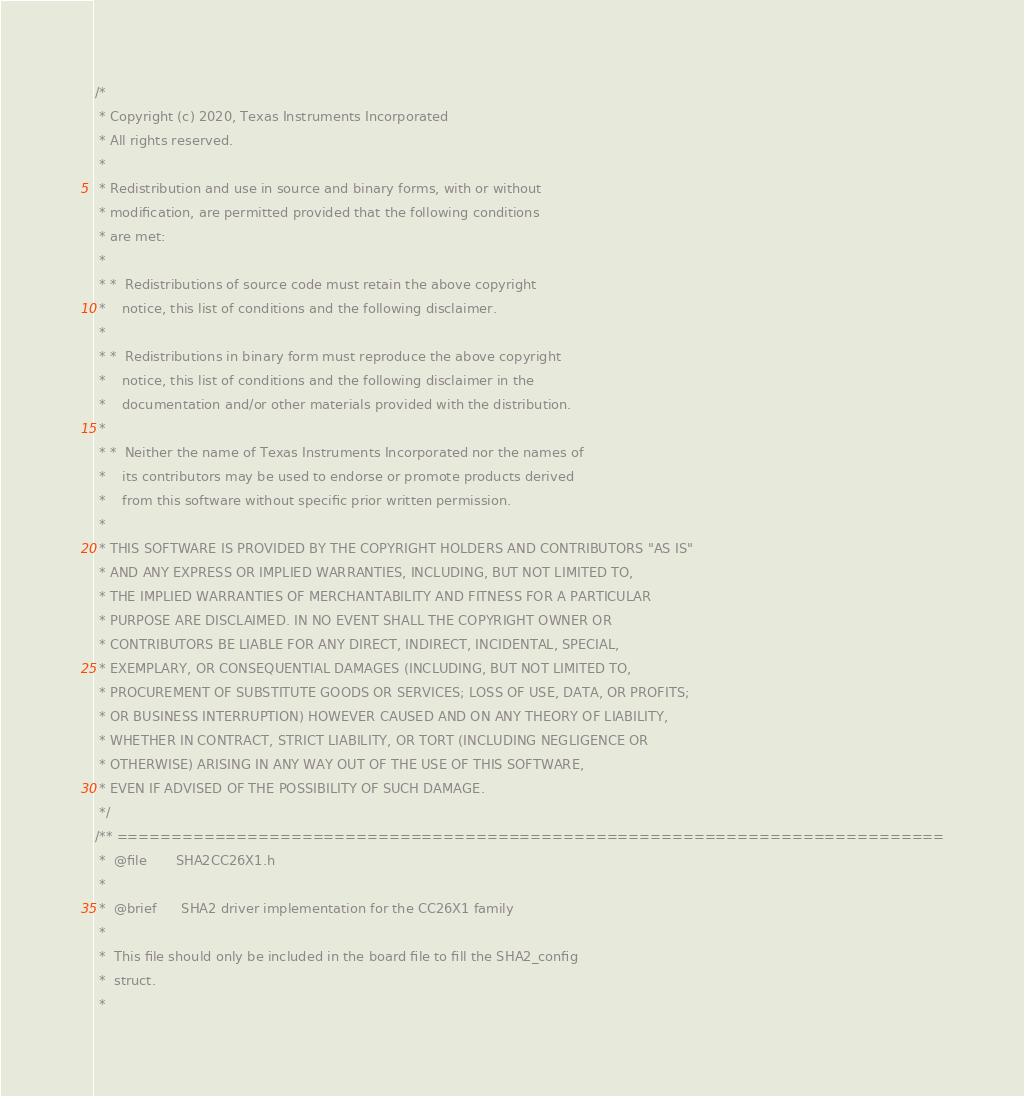Convert code to text. <code><loc_0><loc_0><loc_500><loc_500><_C_>/*
 * Copyright (c) 2020, Texas Instruments Incorporated
 * All rights reserved.
 *
 * Redistribution and use in source and binary forms, with or without
 * modification, are permitted provided that the following conditions
 * are met:
 *
 * *  Redistributions of source code must retain the above copyright
 *    notice, this list of conditions and the following disclaimer.
 *
 * *  Redistributions in binary form must reproduce the above copyright
 *    notice, this list of conditions and the following disclaimer in the
 *    documentation and/or other materials provided with the distribution.
 *
 * *  Neither the name of Texas Instruments Incorporated nor the names of
 *    its contributors may be used to endorse or promote products derived
 *    from this software without specific prior written permission.
 *
 * THIS SOFTWARE IS PROVIDED BY THE COPYRIGHT HOLDERS AND CONTRIBUTORS "AS IS"
 * AND ANY EXPRESS OR IMPLIED WARRANTIES, INCLUDING, BUT NOT LIMITED TO,
 * THE IMPLIED WARRANTIES OF MERCHANTABILITY AND FITNESS FOR A PARTICULAR
 * PURPOSE ARE DISCLAIMED. IN NO EVENT SHALL THE COPYRIGHT OWNER OR
 * CONTRIBUTORS BE LIABLE FOR ANY DIRECT, INDIRECT, INCIDENTAL, SPECIAL,
 * EXEMPLARY, OR CONSEQUENTIAL DAMAGES (INCLUDING, BUT NOT LIMITED TO,
 * PROCUREMENT OF SUBSTITUTE GOODS OR SERVICES; LOSS OF USE, DATA, OR PROFITS;
 * OR BUSINESS INTERRUPTION) HOWEVER CAUSED AND ON ANY THEORY OF LIABILITY,
 * WHETHER IN CONTRACT, STRICT LIABILITY, OR TORT (INCLUDING NEGLIGENCE OR
 * OTHERWISE) ARISING IN ANY WAY OUT OF THE USE OF THIS SOFTWARE,
 * EVEN IF ADVISED OF THE POSSIBILITY OF SUCH DAMAGE.
 */
/** ============================================================================
 *  @file       SHA2CC26X1.h
 *
 *  @brief      SHA2 driver implementation for the CC26X1 family
 *
 *  This file should only be included in the board file to fill the SHA2_config
 *  struct.
 *</code> 